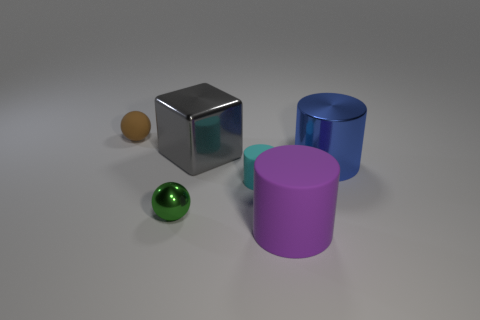Add 3 gray shiny things. How many objects exist? 9 Subtract all cubes. How many objects are left? 5 Subtract 0 yellow spheres. How many objects are left? 6 Subtract all small metallic objects. Subtract all purple matte cylinders. How many objects are left? 4 Add 5 brown things. How many brown things are left? 6 Add 1 gray cubes. How many gray cubes exist? 2 